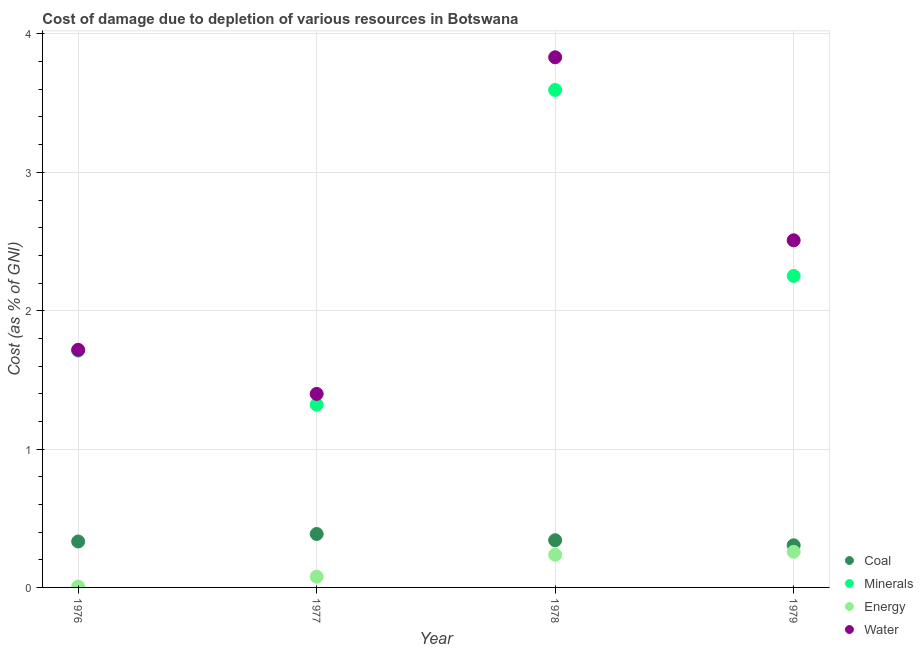How many different coloured dotlines are there?
Your answer should be very brief. 4. Is the number of dotlines equal to the number of legend labels?
Give a very brief answer. Yes. What is the cost of damage due to depletion of minerals in 1978?
Ensure brevity in your answer.  3.6. Across all years, what is the maximum cost of damage due to depletion of water?
Give a very brief answer. 3.83. Across all years, what is the minimum cost of damage due to depletion of energy?
Your response must be concise. 0.01. In which year was the cost of damage due to depletion of minerals maximum?
Your answer should be compact. 1978. In which year was the cost of damage due to depletion of coal minimum?
Your answer should be compact. 1979. What is the total cost of damage due to depletion of coal in the graph?
Keep it short and to the point. 1.36. What is the difference between the cost of damage due to depletion of energy in 1977 and that in 1978?
Keep it short and to the point. -0.16. What is the difference between the cost of damage due to depletion of energy in 1979 and the cost of damage due to depletion of coal in 1978?
Provide a succinct answer. -0.08. What is the average cost of damage due to depletion of energy per year?
Give a very brief answer. 0.14. In the year 1977, what is the difference between the cost of damage due to depletion of coal and cost of damage due to depletion of energy?
Provide a succinct answer. 0.31. What is the ratio of the cost of damage due to depletion of coal in 1978 to that in 1979?
Keep it short and to the point. 1.12. Is the cost of damage due to depletion of water in 1978 less than that in 1979?
Make the answer very short. No. Is the difference between the cost of damage due to depletion of coal in 1978 and 1979 greater than the difference between the cost of damage due to depletion of energy in 1978 and 1979?
Your response must be concise. Yes. What is the difference between the highest and the second highest cost of damage due to depletion of water?
Provide a short and direct response. 1.32. What is the difference between the highest and the lowest cost of damage due to depletion of minerals?
Provide a succinct answer. 2.27. In how many years, is the cost of damage due to depletion of energy greater than the average cost of damage due to depletion of energy taken over all years?
Give a very brief answer. 2. Is the sum of the cost of damage due to depletion of water in 1976 and 1979 greater than the maximum cost of damage due to depletion of energy across all years?
Make the answer very short. Yes. Is it the case that in every year, the sum of the cost of damage due to depletion of energy and cost of damage due to depletion of minerals is greater than the sum of cost of damage due to depletion of coal and cost of damage due to depletion of water?
Your answer should be compact. Yes. Does the cost of damage due to depletion of energy monotonically increase over the years?
Provide a succinct answer. Yes. Is the cost of damage due to depletion of minerals strictly less than the cost of damage due to depletion of energy over the years?
Your answer should be very brief. No. How many dotlines are there?
Ensure brevity in your answer.  4. Are the values on the major ticks of Y-axis written in scientific E-notation?
Make the answer very short. No. Where does the legend appear in the graph?
Make the answer very short. Bottom right. What is the title of the graph?
Your answer should be very brief. Cost of damage due to depletion of various resources in Botswana . What is the label or title of the X-axis?
Keep it short and to the point. Year. What is the label or title of the Y-axis?
Offer a very short reply. Cost (as % of GNI). What is the Cost (as % of GNI) of Coal in 1976?
Keep it short and to the point. 0.33. What is the Cost (as % of GNI) in Minerals in 1976?
Ensure brevity in your answer.  1.71. What is the Cost (as % of GNI) in Energy in 1976?
Your response must be concise. 0.01. What is the Cost (as % of GNI) in Water in 1976?
Offer a terse response. 1.72. What is the Cost (as % of GNI) of Coal in 1977?
Offer a very short reply. 0.39. What is the Cost (as % of GNI) in Minerals in 1977?
Offer a very short reply. 1.32. What is the Cost (as % of GNI) in Energy in 1977?
Keep it short and to the point. 0.08. What is the Cost (as % of GNI) in Water in 1977?
Make the answer very short. 1.4. What is the Cost (as % of GNI) in Coal in 1978?
Offer a very short reply. 0.34. What is the Cost (as % of GNI) of Minerals in 1978?
Make the answer very short. 3.6. What is the Cost (as % of GNI) in Energy in 1978?
Your answer should be compact. 0.24. What is the Cost (as % of GNI) of Water in 1978?
Keep it short and to the point. 3.83. What is the Cost (as % of GNI) of Coal in 1979?
Provide a succinct answer. 0.3. What is the Cost (as % of GNI) in Minerals in 1979?
Give a very brief answer. 2.25. What is the Cost (as % of GNI) in Energy in 1979?
Give a very brief answer. 0.26. What is the Cost (as % of GNI) in Water in 1979?
Your answer should be compact. 2.51. Across all years, what is the maximum Cost (as % of GNI) in Coal?
Your answer should be compact. 0.39. Across all years, what is the maximum Cost (as % of GNI) in Minerals?
Provide a succinct answer. 3.6. Across all years, what is the maximum Cost (as % of GNI) of Energy?
Give a very brief answer. 0.26. Across all years, what is the maximum Cost (as % of GNI) of Water?
Provide a short and direct response. 3.83. Across all years, what is the minimum Cost (as % of GNI) in Coal?
Your answer should be very brief. 0.3. Across all years, what is the minimum Cost (as % of GNI) in Minerals?
Provide a succinct answer. 1.32. Across all years, what is the minimum Cost (as % of GNI) of Energy?
Provide a succinct answer. 0.01. Across all years, what is the minimum Cost (as % of GNI) in Water?
Give a very brief answer. 1.4. What is the total Cost (as % of GNI) in Coal in the graph?
Keep it short and to the point. 1.36. What is the total Cost (as % of GNI) of Minerals in the graph?
Provide a short and direct response. 8.88. What is the total Cost (as % of GNI) in Energy in the graph?
Your answer should be very brief. 0.58. What is the total Cost (as % of GNI) of Water in the graph?
Your answer should be compact. 9.46. What is the difference between the Cost (as % of GNI) in Coal in 1976 and that in 1977?
Your answer should be compact. -0.05. What is the difference between the Cost (as % of GNI) in Minerals in 1976 and that in 1977?
Provide a short and direct response. 0.39. What is the difference between the Cost (as % of GNI) in Energy in 1976 and that in 1977?
Ensure brevity in your answer.  -0.07. What is the difference between the Cost (as % of GNI) of Water in 1976 and that in 1977?
Your answer should be very brief. 0.32. What is the difference between the Cost (as % of GNI) in Coal in 1976 and that in 1978?
Give a very brief answer. -0.01. What is the difference between the Cost (as % of GNI) of Minerals in 1976 and that in 1978?
Provide a succinct answer. -1.88. What is the difference between the Cost (as % of GNI) in Energy in 1976 and that in 1978?
Your response must be concise. -0.23. What is the difference between the Cost (as % of GNI) of Water in 1976 and that in 1978?
Give a very brief answer. -2.11. What is the difference between the Cost (as % of GNI) of Coal in 1976 and that in 1979?
Offer a terse response. 0.03. What is the difference between the Cost (as % of GNI) of Minerals in 1976 and that in 1979?
Make the answer very short. -0.54. What is the difference between the Cost (as % of GNI) in Energy in 1976 and that in 1979?
Provide a short and direct response. -0.25. What is the difference between the Cost (as % of GNI) in Water in 1976 and that in 1979?
Provide a succinct answer. -0.79. What is the difference between the Cost (as % of GNI) in Coal in 1977 and that in 1978?
Ensure brevity in your answer.  0.05. What is the difference between the Cost (as % of GNI) of Minerals in 1977 and that in 1978?
Your response must be concise. -2.27. What is the difference between the Cost (as % of GNI) of Energy in 1977 and that in 1978?
Provide a succinct answer. -0.16. What is the difference between the Cost (as % of GNI) of Water in 1977 and that in 1978?
Keep it short and to the point. -2.43. What is the difference between the Cost (as % of GNI) in Coal in 1977 and that in 1979?
Provide a short and direct response. 0.08. What is the difference between the Cost (as % of GNI) in Minerals in 1977 and that in 1979?
Provide a short and direct response. -0.93. What is the difference between the Cost (as % of GNI) in Energy in 1977 and that in 1979?
Provide a succinct answer. -0.18. What is the difference between the Cost (as % of GNI) of Water in 1977 and that in 1979?
Keep it short and to the point. -1.11. What is the difference between the Cost (as % of GNI) in Coal in 1978 and that in 1979?
Offer a terse response. 0.04. What is the difference between the Cost (as % of GNI) of Minerals in 1978 and that in 1979?
Offer a terse response. 1.34. What is the difference between the Cost (as % of GNI) in Energy in 1978 and that in 1979?
Provide a succinct answer. -0.02. What is the difference between the Cost (as % of GNI) of Water in 1978 and that in 1979?
Ensure brevity in your answer.  1.32. What is the difference between the Cost (as % of GNI) in Coal in 1976 and the Cost (as % of GNI) in Minerals in 1977?
Keep it short and to the point. -0.99. What is the difference between the Cost (as % of GNI) in Coal in 1976 and the Cost (as % of GNI) in Energy in 1977?
Ensure brevity in your answer.  0.25. What is the difference between the Cost (as % of GNI) of Coal in 1976 and the Cost (as % of GNI) of Water in 1977?
Offer a very short reply. -1.07. What is the difference between the Cost (as % of GNI) in Minerals in 1976 and the Cost (as % of GNI) in Energy in 1977?
Keep it short and to the point. 1.63. What is the difference between the Cost (as % of GNI) in Minerals in 1976 and the Cost (as % of GNI) in Water in 1977?
Keep it short and to the point. 0.31. What is the difference between the Cost (as % of GNI) in Energy in 1976 and the Cost (as % of GNI) in Water in 1977?
Your response must be concise. -1.39. What is the difference between the Cost (as % of GNI) of Coal in 1976 and the Cost (as % of GNI) of Minerals in 1978?
Your response must be concise. -3.26. What is the difference between the Cost (as % of GNI) in Coal in 1976 and the Cost (as % of GNI) in Energy in 1978?
Your answer should be very brief. 0.1. What is the difference between the Cost (as % of GNI) of Coal in 1976 and the Cost (as % of GNI) of Water in 1978?
Make the answer very short. -3.5. What is the difference between the Cost (as % of GNI) in Minerals in 1976 and the Cost (as % of GNI) in Energy in 1978?
Your answer should be very brief. 1.48. What is the difference between the Cost (as % of GNI) in Minerals in 1976 and the Cost (as % of GNI) in Water in 1978?
Give a very brief answer. -2.12. What is the difference between the Cost (as % of GNI) of Energy in 1976 and the Cost (as % of GNI) of Water in 1978?
Keep it short and to the point. -3.83. What is the difference between the Cost (as % of GNI) of Coal in 1976 and the Cost (as % of GNI) of Minerals in 1979?
Offer a terse response. -1.92. What is the difference between the Cost (as % of GNI) of Coal in 1976 and the Cost (as % of GNI) of Energy in 1979?
Make the answer very short. 0.07. What is the difference between the Cost (as % of GNI) in Coal in 1976 and the Cost (as % of GNI) in Water in 1979?
Offer a terse response. -2.18. What is the difference between the Cost (as % of GNI) of Minerals in 1976 and the Cost (as % of GNI) of Energy in 1979?
Offer a terse response. 1.45. What is the difference between the Cost (as % of GNI) in Minerals in 1976 and the Cost (as % of GNI) in Water in 1979?
Ensure brevity in your answer.  -0.8. What is the difference between the Cost (as % of GNI) in Energy in 1976 and the Cost (as % of GNI) in Water in 1979?
Give a very brief answer. -2.5. What is the difference between the Cost (as % of GNI) of Coal in 1977 and the Cost (as % of GNI) of Minerals in 1978?
Your answer should be very brief. -3.21. What is the difference between the Cost (as % of GNI) of Coal in 1977 and the Cost (as % of GNI) of Energy in 1978?
Your answer should be compact. 0.15. What is the difference between the Cost (as % of GNI) of Coal in 1977 and the Cost (as % of GNI) of Water in 1978?
Your answer should be very brief. -3.45. What is the difference between the Cost (as % of GNI) of Minerals in 1977 and the Cost (as % of GNI) of Energy in 1978?
Your response must be concise. 1.08. What is the difference between the Cost (as % of GNI) in Minerals in 1977 and the Cost (as % of GNI) in Water in 1978?
Ensure brevity in your answer.  -2.51. What is the difference between the Cost (as % of GNI) of Energy in 1977 and the Cost (as % of GNI) of Water in 1978?
Keep it short and to the point. -3.75. What is the difference between the Cost (as % of GNI) of Coal in 1977 and the Cost (as % of GNI) of Minerals in 1979?
Your answer should be compact. -1.86. What is the difference between the Cost (as % of GNI) of Coal in 1977 and the Cost (as % of GNI) of Energy in 1979?
Keep it short and to the point. 0.13. What is the difference between the Cost (as % of GNI) in Coal in 1977 and the Cost (as % of GNI) in Water in 1979?
Make the answer very short. -2.12. What is the difference between the Cost (as % of GNI) of Minerals in 1977 and the Cost (as % of GNI) of Energy in 1979?
Offer a very short reply. 1.06. What is the difference between the Cost (as % of GNI) in Minerals in 1977 and the Cost (as % of GNI) in Water in 1979?
Your response must be concise. -1.19. What is the difference between the Cost (as % of GNI) in Energy in 1977 and the Cost (as % of GNI) in Water in 1979?
Keep it short and to the point. -2.43. What is the difference between the Cost (as % of GNI) in Coal in 1978 and the Cost (as % of GNI) in Minerals in 1979?
Your response must be concise. -1.91. What is the difference between the Cost (as % of GNI) in Coal in 1978 and the Cost (as % of GNI) in Energy in 1979?
Keep it short and to the point. 0.08. What is the difference between the Cost (as % of GNI) of Coal in 1978 and the Cost (as % of GNI) of Water in 1979?
Ensure brevity in your answer.  -2.17. What is the difference between the Cost (as % of GNI) of Minerals in 1978 and the Cost (as % of GNI) of Energy in 1979?
Your response must be concise. 3.34. What is the difference between the Cost (as % of GNI) in Minerals in 1978 and the Cost (as % of GNI) in Water in 1979?
Offer a terse response. 1.09. What is the difference between the Cost (as % of GNI) in Energy in 1978 and the Cost (as % of GNI) in Water in 1979?
Make the answer very short. -2.27. What is the average Cost (as % of GNI) in Coal per year?
Provide a short and direct response. 0.34. What is the average Cost (as % of GNI) of Minerals per year?
Ensure brevity in your answer.  2.22. What is the average Cost (as % of GNI) of Energy per year?
Ensure brevity in your answer.  0.14. What is the average Cost (as % of GNI) in Water per year?
Make the answer very short. 2.36. In the year 1976, what is the difference between the Cost (as % of GNI) in Coal and Cost (as % of GNI) in Minerals?
Make the answer very short. -1.38. In the year 1976, what is the difference between the Cost (as % of GNI) in Coal and Cost (as % of GNI) in Energy?
Your answer should be compact. 0.33. In the year 1976, what is the difference between the Cost (as % of GNI) of Coal and Cost (as % of GNI) of Water?
Your response must be concise. -1.39. In the year 1976, what is the difference between the Cost (as % of GNI) in Minerals and Cost (as % of GNI) in Energy?
Make the answer very short. 1.71. In the year 1976, what is the difference between the Cost (as % of GNI) in Minerals and Cost (as % of GNI) in Water?
Provide a short and direct response. -0.01. In the year 1976, what is the difference between the Cost (as % of GNI) in Energy and Cost (as % of GNI) in Water?
Offer a very short reply. -1.71. In the year 1977, what is the difference between the Cost (as % of GNI) of Coal and Cost (as % of GNI) of Minerals?
Your response must be concise. -0.93. In the year 1977, what is the difference between the Cost (as % of GNI) in Coal and Cost (as % of GNI) in Energy?
Give a very brief answer. 0.31. In the year 1977, what is the difference between the Cost (as % of GNI) of Coal and Cost (as % of GNI) of Water?
Offer a terse response. -1.01. In the year 1977, what is the difference between the Cost (as % of GNI) of Minerals and Cost (as % of GNI) of Energy?
Make the answer very short. 1.24. In the year 1977, what is the difference between the Cost (as % of GNI) of Minerals and Cost (as % of GNI) of Water?
Keep it short and to the point. -0.08. In the year 1977, what is the difference between the Cost (as % of GNI) of Energy and Cost (as % of GNI) of Water?
Give a very brief answer. -1.32. In the year 1978, what is the difference between the Cost (as % of GNI) of Coal and Cost (as % of GNI) of Minerals?
Your response must be concise. -3.25. In the year 1978, what is the difference between the Cost (as % of GNI) of Coal and Cost (as % of GNI) of Energy?
Offer a terse response. 0.1. In the year 1978, what is the difference between the Cost (as % of GNI) of Coal and Cost (as % of GNI) of Water?
Ensure brevity in your answer.  -3.49. In the year 1978, what is the difference between the Cost (as % of GNI) in Minerals and Cost (as % of GNI) in Energy?
Provide a short and direct response. 3.36. In the year 1978, what is the difference between the Cost (as % of GNI) in Minerals and Cost (as % of GNI) in Water?
Your answer should be compact. -0.24. In the year 1978, what is the difference between the Cost (as % of GNI) in Energy and Cost (as % of GNI) in Water?
Provide a short and direct response. -3.6. In the year 1979, what is the difference between the Cost (as % of GNI) in Coal and Cost (as % of GNI) in Minerals?
Your response must be concise. -1.95. In the year 1979, what is the difference between the Cost (as % of GNI) in Coal and Cost (as % of GNI) in Energy?
Give a very brief answer. 0.05. In the year 1979, what is the difference between the Cost (as % of GNI) of Coal and Cost (as % of GNI) of Water?
Provide a short and direct response. -2.2. In the year 1979, what is the difference between the Cost (as % of GNI) of Minerals and Cost (as % of GNI) of Energy?
Offer a terse response. 1.99. In the year 1979, what is the difference between the Cost (as % of GNI) in Minerals and Cost (as % of GNI) in Water?
Ensure brevity in your answer.  -0.26. In the year 1979, what is the difference between the Cost (as % of GNI) of Energy and Cost (as % of GNI) of Water?
Give a very brief answer. -2.25. What is the ratio of the Cost (as % of GNI) of Coal in 1976 to that in 1977?
Keep it short and to the point. 0.86. What is the ratio of the Cost (as % of GNI) in Minerals in 1976 to that in 1977?
Ensure brevity in your answer.  1.3. What is the ratio of the Cost (as % of GNI) of Energy in 1976 to that in 1977?
Make the answer very short. 0.08. What is the ratio of the Cost (as % of GNI) of Water in 1976 to that in 1977?
Ensure brevity in your answer.  1.23. What is the ratio of the Cost (as % of GNI) in Coal in 1976 to that in 1978?
Provide a succinct answer. 0.97. What is the ratio of the Cost (as % of GNI) of Minerals in 1976 to that in 1978?
Your response must be concise. 0.48. What is the ratio of the Cost (as % of GNI) of Energy in 1976 to that in 1978?
Ensure brevity in your answer.  0.03. What is the ratio of the Cost (as % of GNI) of Water in 1976 to that in 1978?
Offer a very short reply. 0.45. What is the ratio of the Cost (as % of GNI) of Coal in 1976 to that in 1979?
Make the answer very short. 1.09. What is the ratio of the Cost (as % of GNI) in Minerals in 1976 to that in 1979?
Offer a very short reply. 0.76. What is the ratio of the Cost (as % of GNI) in Energy in 1976 to that in 1979?
Keep it short and to the point. 0.02. What is the ratio of the Cost (as % of GNI) in Water in 1976 to that in 1979?
Give a very brief answer. 0.68. What is the ratio of the Cost (as % of GNI) in Coal in 1977 to that in 1978?
Provide a succinct answer. 1.13. What is the ratio of the Cost (as % of GNI) of Minerals in 1977 to that in 1978?
Your answer should be very brief. 0.37. What is the ratio of the Cost (as % of GNI) in Energy in 1977 to that in 1978?
Your answer should be compact. 0.33. What is the ratio of the Cost (as % of GNI) of Water in 1977 to that in 1978?
Provide a succinct answer. 0.37. What is the ratio of the Cost (as % of GNI) of Coal in 1977 to that in 1979?
Offer a very short reply. 1.27. What is the ratio of the Cost (as % of GNI) of Minerals in 1977 to that in 1979?
Your answer should be very brief. 0.59. What is the ratio of the Cost (as % of GNI) in Energy in 1977 to that in 1979?
Provide a short and direct response. 0.3. What is the ratio of the Cost (as % of GNI) of Water in 1977 to that in 1979?
Your answer should be very brief. 0.56. What is the ratio of the Cost (as % of GNI) in Coal in 1978 to that in 1979?
Your answer should be compact. 1.12. What is the ratio of the Cost (as % of GNI) in Minerals in 1978 to that in 1979?
Keep it short and to the point. 1.6. What is the ratio of the Cost (as % of GNI) in Energy in 1978 to that in 1979?
Offer a terse response. 0.92. What is the ratio of the Cost (as % of GNI) in Water in 1978 to that in 1979?
Offer a very short reply. 1.53. What is the difference between the highest and the second highest Cost (as % of GNI) of Coal?
Your response must be concise. 0.05. What is the difference between the highest and the second highest Cost (as % of GNI) in Minerals?
Provide a short and direct response. 1.34. What is the difference between the highest and the second highest Cost (as % of GNI) of Energy?
Provide a short and direct response. 0.02. What is the difference between the highest and the second highest Cost (as % of GNI) of Water?
Your answer should be compact. 1.32. What is the difference between the highest and the lowest Cost (as % of GNI) in Coal?
Make the answer very short. 0.08. What is the difference between the highest and the lowest Cost (as % of GNI) of Minerals?
Give a very brief answer. 2.27. What is the difference between the highest and the lowest Cost (as % of GNI) in Energy?
Provide a short and direct response. 0.25. What is the difference between the highest and the lowest Cost (as % of GNI) in Water?
Provide a succinct answer. 2.43. 